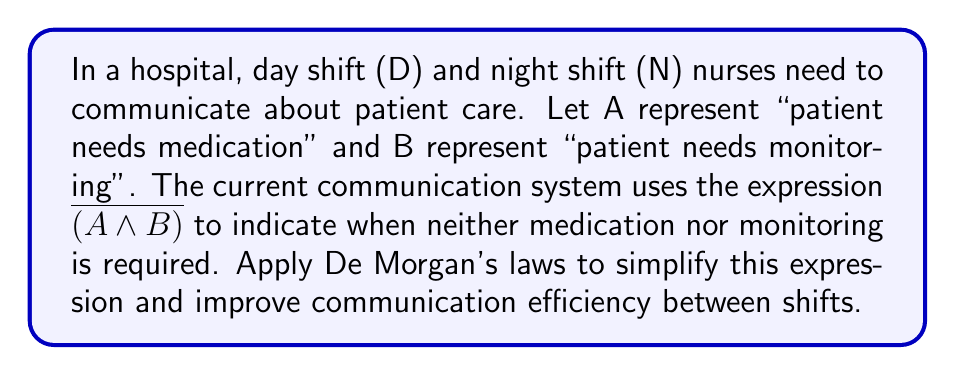Provide a solution to this math problem. To simplify the expression $\overline{(A \land B)}$ using De Morgan's laws, we follow these steps:

1. Recall De Morgan's law for the negation of a conjunction:
   $\overline{(P \land Q)} \equiv \overline{P} \lor \overline{Q}$

2. Apply this law to our expression:
   $\overline{(A \land B)} \equiv \overline{A} \lor \overline{B}$

3. Interpret the result:
   - $\overline{A}$ means "patient does not need medication"
   - $\overline{B}$ means "patient does not need monitoring"
   - $\overline{A} \lor \overline{B}$ means "patient does not need medication OR does not need monitoring"

This simplified expression is logically equivalent to the original but allows for more efficient communication between shifts. Nurses can now report on each aspect (medication and monitoring) separately, which is often more practical in a healthcare setting.
Answer: $\overline{A} \lor \overline{B}$ 